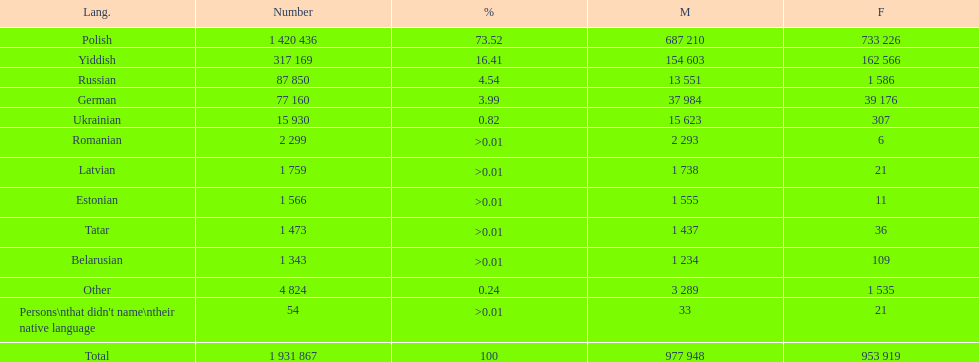What was the top language from the one's whose percentage was >0.01 Romanian. 